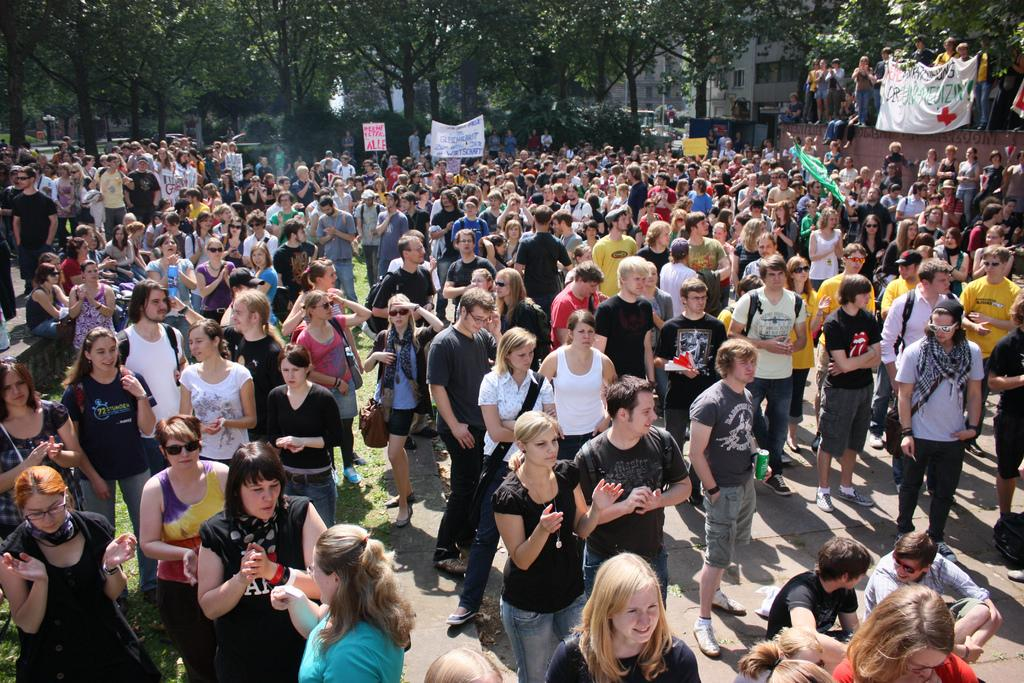What is the main subject of the image? The main subject of the image is a crowd. What are some people in the crowd wearing? Some people in the crowd are wearing bags and goggles. What are some people in the crowd holding? A few people in the crowd are holding banners. What can be seen in the background of the image? There are trees and a building in the background of the image. What type of clouds can be seen in the image? There are no clouds visible in the image; it features a crowd with people wearing bags and goggles, holding banners, and standing in front of trees and a building. 